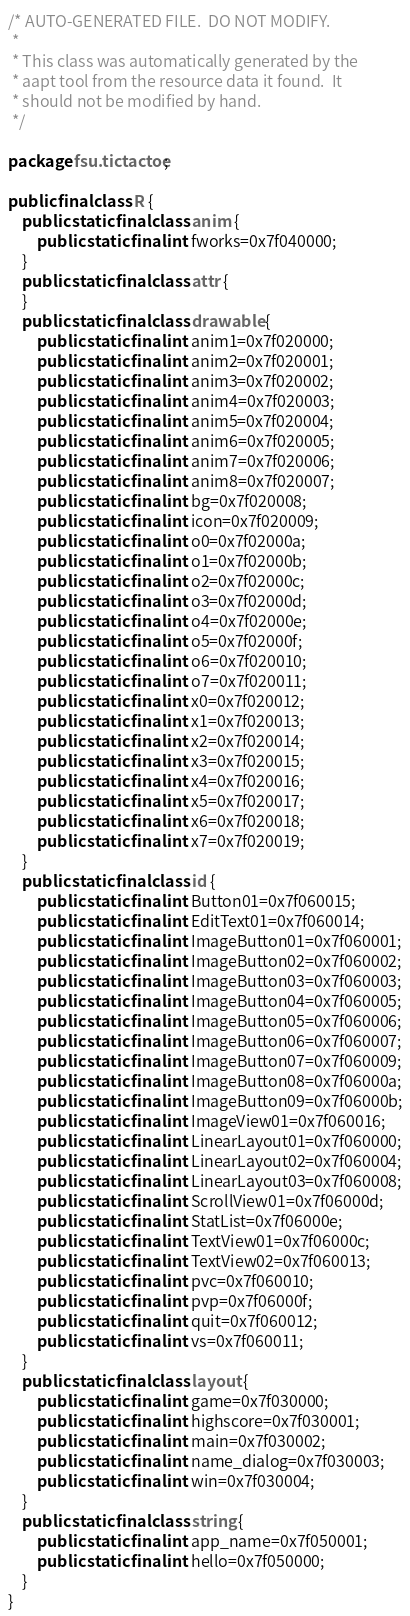<code> <loc_0><loc_0><loc_500><loc_500><_Java_>/* AUTO-GENERATED FILE.  DO NOT MODIFY.
 *
 * This class was automatically generated by the
 * aapt tool from the resource data it found.  It
 * should not be modified by hand.
 */

package fsu.tictactoe;

public final class R {
    public static final class anim {
        public static final int fworks=0x7f040000;
    }
    public static final class attr {
    }
    public static final class drawable {
        public static final int anim1=0x7f020000;
        public static final int anim2=0x7f020001;
        public static final int anim3=0x7f020002;
        public static final int anim4=0x7f020003;
        public static final int anim5=0x7f020004;
        public static final int anim6=0x7f020005;
        public static final int anim7=0x7f020006;
        public static final int anim8=0x7f020007;
        public static final int bg=0x7f020008;
        public static final int icon=0x7f020009;
        public static final int o0=0x7f02000a;
        public static final int o1=0x7f02000b;
        public static final int o2=0x7f02000c;
        public static final int o3=0x7f02000d;
        public static final int o4=0x7f02000e;
        public static final int o5=0x7f02000f;
        public static final int o6=0x7f020010;
        public static final int o7=0x7f020011;
        public static final int x0=0x7f020012;
        public static final int x1=0x7f020013;
        public static final int x2=0x7f020014;
        public static final int x3=0x7f020015;
        public static final int x4=0x7f020016;
        public static final int x5=0x7f020017;
        public static final int x6=0x7f020018;
        public static final int x7=0x7f020019;
    }
    public static final class id {
        public static final int Button01=0x7f060015;
        public static final int EditText01=0x7f060014;
        public static final int ImageButton01=0x7f060001;
        public static final int ImageButton02=0x7f060002;
        public static final int ImageButton03=0x7f060003;
        public static final int ImageButton04=0x7f060005;
        public static final int ImageButton05=0x7f060006;
        public static final int ImageButton06=0x7f060007;
        public static final int ImageButton07=0x7f060009;
        public static final int ImageButton08=0x7f06000a;
        public static final int ImageButton09=0x7f06000b;
        public static final int ImageView01=0x7f060016;
        public static final int LinearLayout01=0x7f060000;
        public static final int LinearLayout02=0x7f060004;
        public static final int LinearLayout03=0x7f060008;
        public static final int ScrollView01=0x7f06000d;
        public static final int StatList=0x7f06000e;
        public static final int TextView01=0x7f06000c;
        public static final int TextView02=0x7f060013;
        public static final int pvc=0x7f060010;
        public static final int pvp=0x7f06000f;
        public static final int quit=0x7f060012;
        public static final int vs=0x7f060011;
    }
    public static final class layout {
        public static final int game=0x7f030000;
        public static final int highscore=0x7f030001;
        public static final int main=0x7f030002;
        public static final int name_dialog=0x7f030003;
        public static final int win=0x7f030004;
    }
    public static final class string {
        public static final int app_name=0x7f050001;
        public static final int hello=0x7f050000;
    }
}
</code> 